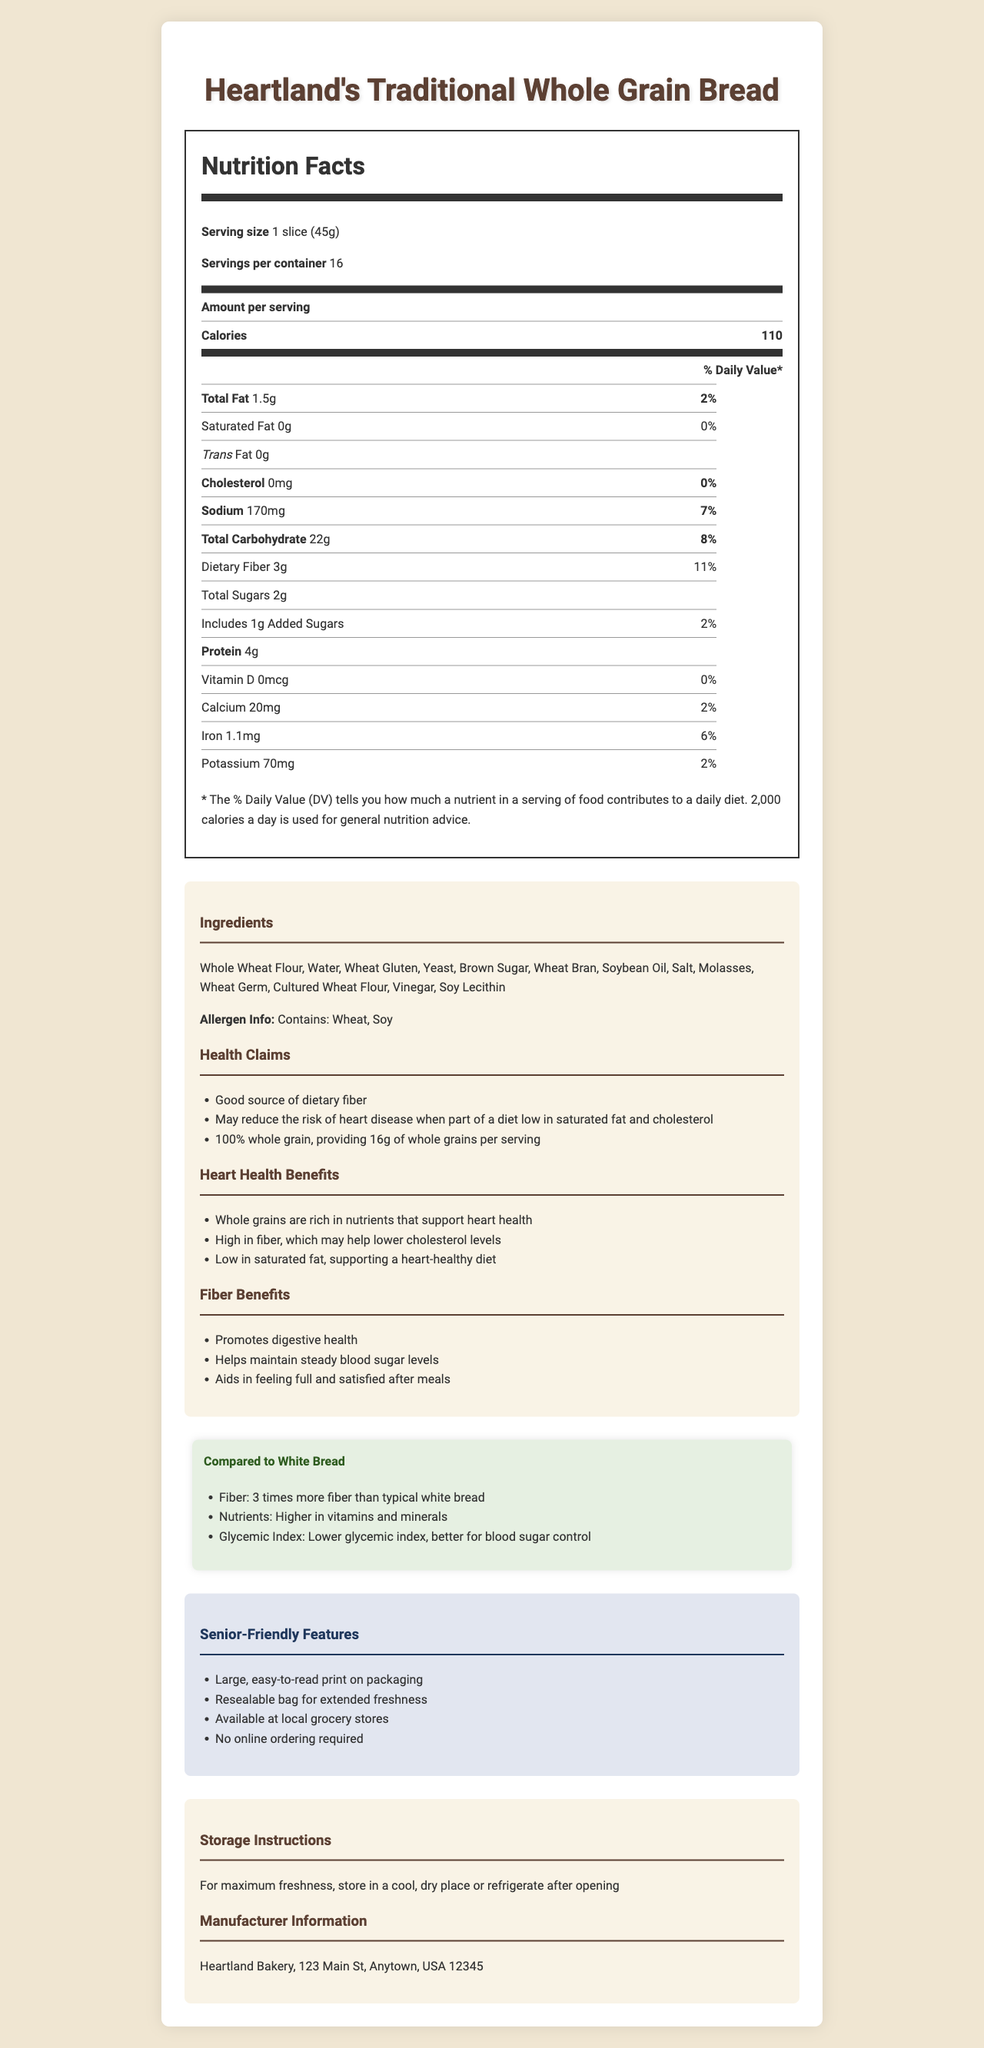what is the serving size of Heartland's Traditional Whole Grain Bread? The serving size is listed as "1 slice (45g)" on the Nutrition Facts label.
Answer: 1 slice (45g) How many servings are there per container? The Nutrition Facts label indicates there are 16 servings per container.
Answer: 16 How much dietary fiber does one serving of this bread provide? The dietary fiber content per serving is described as "3g" on the Nutrition Facts label.
Answer: 3g What percentage of the daily value for dietary fiber does one serving provide? One serving of the bread provides 11% of the daily value of dietary fiber, as indicated on the Nutrition Facts label.
Answer: 11% Does the bread contain any trans fat? The trans fat content is listed as "0g" on the Nutrition Facts label, indicating it contains no trans fat.
Answer: No What are the heart health benefits mentioned for this bread? The document mentions that the bread is rich in nutrients supporting heart health, high in fiber that may help lower cholesterol levels, and low in saturated fat which supports a heart-healthy diet.
Answer: Whole grains are rich in nutrients that support heart health, high in fiber which may help lower cholesterol levels, low in saturated fat supporting a heart-healthy diet Which allergens are present in Heartland's Traditional Whole Grain Bread? The allergen information section states that the bread contains wheat and soy.
Answer: Wheat, Soy Where is Heartland Bakery located? The manufacturer information provided at the end of the document lists the address of Heartland Bakery as "123 Main St, Anytown, USA 12345".
Answer: 123 Main St, Anytown, USA 12345 Why might this bread be a better option compared to white bread? The comparison section explains that this bread has three times more fiber, a higher nutrient density, and a lower glycemic index compared to white bread.
Answer: It has 3 times more fiber, higher nutrient density, and a lower glycemic index Which feature makes the packaging senior-friendly? A. Bold colors B. Large, easy-to-read print C. Plastic wrap D. Small-size loaf The document indicates that one of the senior-friendly features is "Large, easy-to-read print on packaging".
Answer: B How many calories are in a single serving of Heartland's Traditional Whole Grain Bread? A. 90 calories B. 110 calories C. 130 calories D. 150 calories The Nutrition Facts label indicates that there are 110 calories per serving.
Answer: B Does Heartland's Traditional Whole Grain Bread contain any added sugars? The document states that the bread includes "1g" of added sugars.
Answer: Yes Can Heartland's Traditional Whole Grain Bread be ordered online? The senior-friendly features section mentions "No online ordering required," indicating it must be purchased at a local grocery store.
Answer: No Summarize the main idea of this document about Heartland's Traditional Whole Grain Bread. The document is a thorough description of Heartland's Traditional Whole Grain Bread, highlighting its nutritional value, health benefits including its fiber content and heart health implications, comparisons to white bread, and features making it convenient for seniors.
Answer: The document provides detailed nutritional information, ingredients, health benefits focusing on dietary fiber and heart health, comparisons to white bread, and senior-friendly features for Heartland's Traditional Whole Grain Bread. How much protein does one serving of this bread provide? The Nutrition Facts label states that one serving provides "4g" of protein.
Answer: 4g Is there any information about the production methods of the bread? The document does not provide details on the production methods used for making the bread.
Answer: Not enough information 